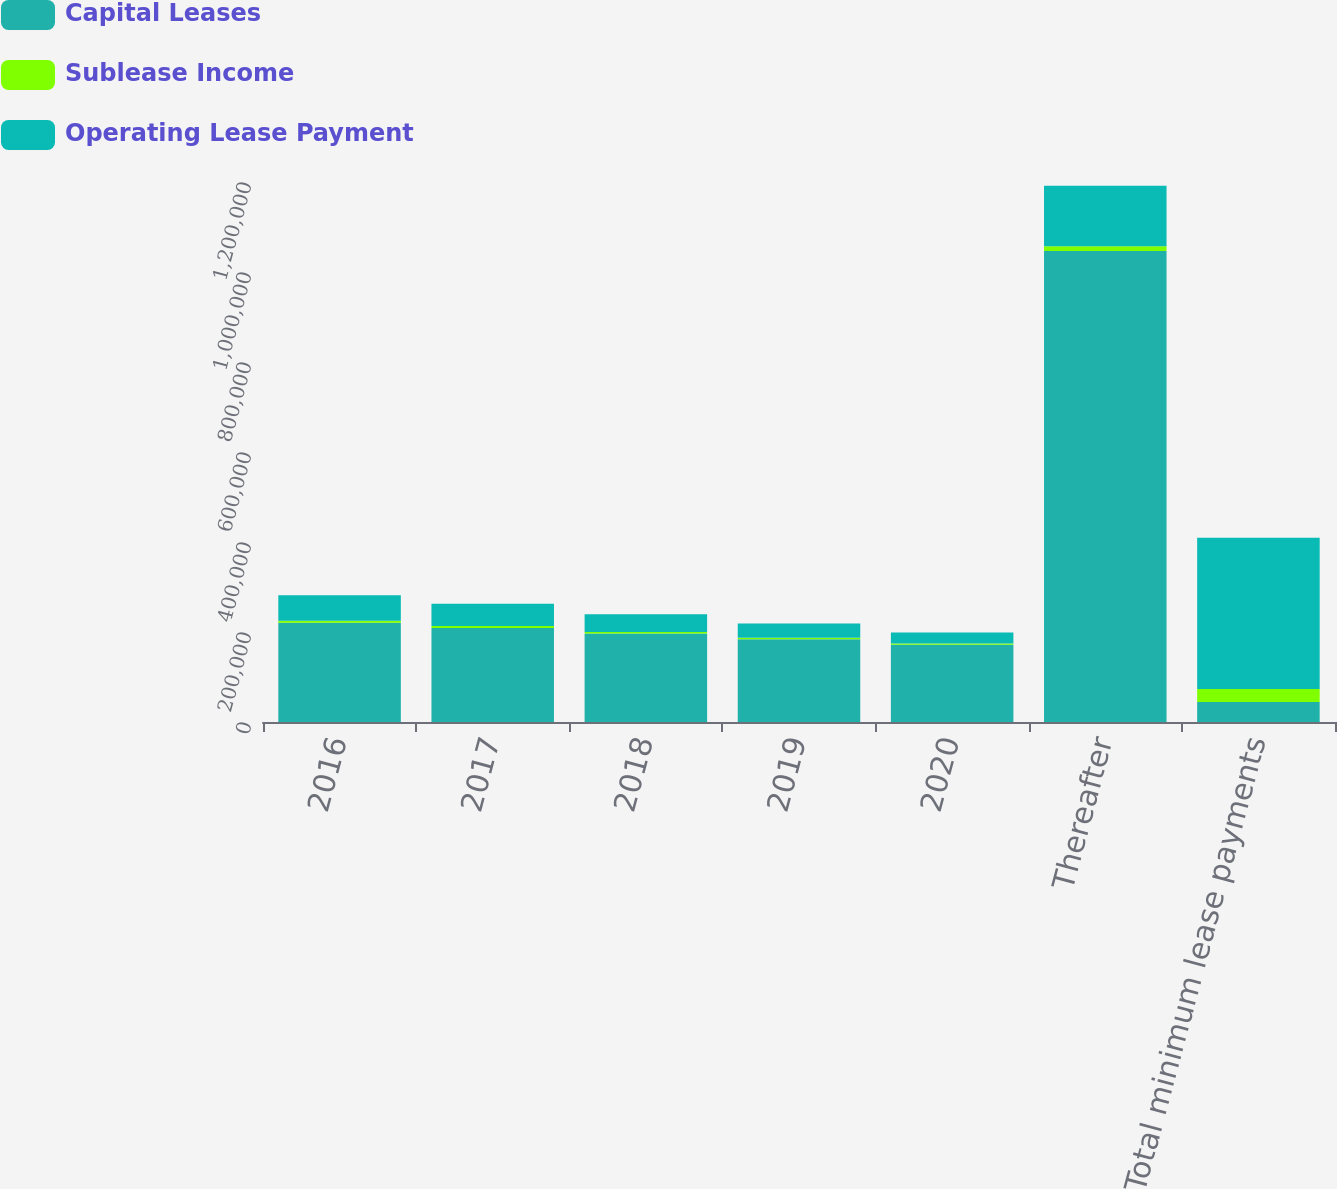<chart> <loc_0><loc_0><loc_500><loc_500><stacked_bar_chart><ecel><fcel>2016<fcel>2017<fcel>2018<fcel>2019<fcel>2020<fcel>Thereafter<fcel>Total minimum lease payments<nl><fcel>Capital Leases<fcel>220357<fcel>208975<fcel>196632<fcel>184157<fcel>171794<fcel>1.0467e+06<fcel>44456.5<nl><fcel>Sublease Income<fcel>4827<fcel>4354<fcel>3316<fcel>2864<fcel>2922<fcel>10327<fcel>28610<nl><fcel>Operating Lease Payment<fcel>56543<fcel>49217<fcel>39696<fcel>31909<fcel>24418<fcel>134532<fcel>336315<nl></chart> 